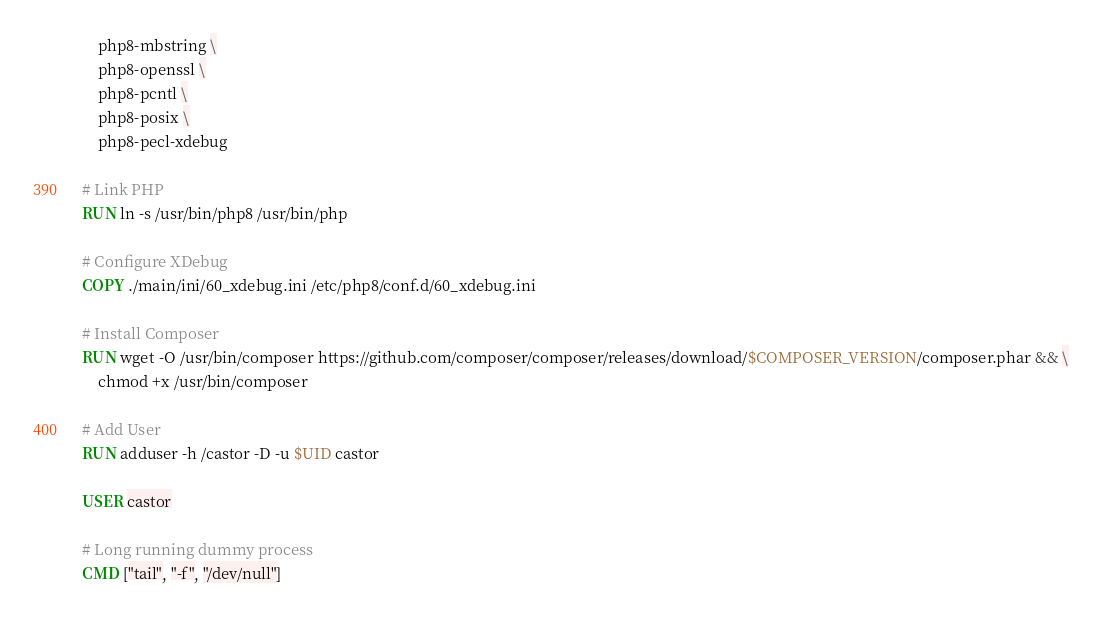Convert code to text. <code><loc_0><loc_0><loc_500><loc_500><_Dockerfile_>    php8-mbstring \
    php8-openssl \
    php8-pcntl \
    php8-posix \
    php8-pecl-xdebug

# Link PHP
RUN ln -s /usr/bin/php8 /usr/bin/php

# Configure XDebug
COPY ./main/ini/60_xdebug.ini /etc/php8/conf.d/60_xdebug.ini

# Install Composer
RUN wget -O /usr/bin/composer https://github.com/composer/composer/releases/download/$COMPOSER_VERSION/composer.phar && \
    chmod +x /usr/bin/composer

# Add User
RUN adduser -h /castor -D -u $UID castor

USER castor

# Long running dummy process
CMD ["tail", "-f", "/dev/null"]</code> 